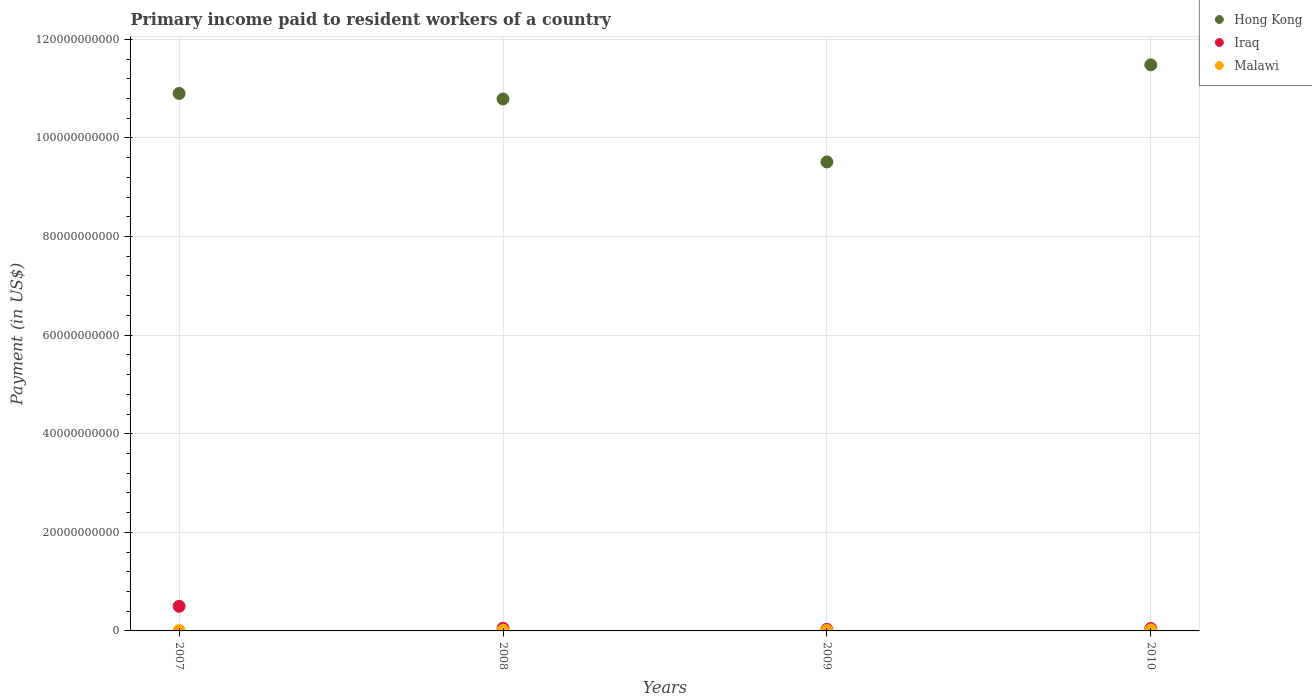What is the amount paid to workers in Hong Kong in 2009?
Ensure brevity in your answer.  9.51e+1. Across all years, what is the maximum amount paid to workers in Hong Kong?
Your answer should be very brief. 1.15e+11. Across all years, what is the minimum amount paid to workers in Hong Kong?
Make the answer very short. 9.51e+1. In which year was the amount paid to workers in Malawi maximum?
Offer a very short reply. 2010. What is the total amount paid to workers in Hong Kong in the graph?
Your answer should be very brief. 4.27e+11. What is the difference between the amount paid to workers in Iraq in 2007 and that in 2010?
Provide a succinct answer. 4.50e+09. What is the difference between the amount paid to workers in Iraq in 2009 and the amount paid to workers in Malawi in 2010?
Your response must be concise. 1.25e+08. What is the average amount paid to workers in Hong Kong per year?
Provide a short and direct response. 1.07e+11. In the year 2010, what is the difference between the amount paid to workers in Iraq and amount paid to workers in Hong Kong?
Provide a short and direct response. -1.14e+11. What is the ratio of the amount paid to workers in Malawi in 2009 to that in 2010?
Your answer should be very brief. 0.64. Is the amount paid to workers in Hong Kong in 2007 less than that in 2010?
Provide a succinct answer. Yes. What is the difference between the highest and the second highest amount paid to workers in Hong Kong?
Your answer should be very brief. 5.80e+09. What is the difference between the highest and the lowest amount paid to workers in Iraq?
Provide a succinct answer. 4.67e+09. In how many years, is the amount paid to workers in Iraq greater than the average amount paid to workers in Iraq taken over all years?
Provide a short and direct response. 1. Does the amount paid to workers in Malawi monotonically increase over the years?
Keep it short and to the point. No. Is the amount paid to workers in Malawi strictly greater than the amount paid to workers in Iraq over the years?
Provide a succinct answer. No. Is the amount paid to workers in Hong Kong strictly less than the amount paid to workers in Malawi over the years?
Offer a terse response. No. Where does the legend appear in the graph?
Your answer should be compact. Top right. What is the title of the graph?
Your response must be concise. Primary income paid to resident workers of a country. Does "Senegal" appear as one of the legend labels in the graph?
Give a very brief answer. No. What is the label or title of the X-axis?
Provide a short and direct response. Years. What is the label or title of the Y-axis?
Your answer should be compact. Payment (in US$). What is the Payment (in US$) in Hong Kong in 2007?
Your answer should be compact. 1.09e+11. What is the Payment (in US$) of Iraq in 2007?
Provide a succinct answer. 4.99e+09. What is the Payment (in US$) of Malawi in 2007?
Offer a very short reply. 8.07e+07. What is the Payment (in US$) in Hong Kong in 2008?
Ensure brevity in your answer.  1.08e+11. What is the Payment (in US$) of Iraq in 2008?
Your answer should be very brief. 5.54e+08. What is the Payment (in US$) in Malawi in 2008?
Give a very brief answer. 1.50e+08. What is the Payment (in US$) of Hong Kong in 2009?
Provide a short and direct response. 9.51e+1. What is the Payment (in US$) of Iraq in 2009?
Your answer should be compact. 3.17e+08. What is the Payment (in US$) in Malawi in 2009?
Make the answer very short. 1.23e+08. What is the Payment (in US$) of Hong Kong in 2010?
Provide a short and direct response. 1.15e+11. What is the Payment (in US$) in Iraq in 2010?
Offer a terse response. 4.87e+08. What is the Payment (in US$) in Malawi in 2010?
Provide a short and direct response. 1.92e+08. Across all years, what is the maximum Payment (in US$) of Hong Kong?
Give a very brief answer. 1.15e+11. Across all years, what is the maximum Payment (in US$) in Iraq?
Offer a terse response. 4.99e+09. Across all years, what is the maximum Payment (in US$) of Malawi?
Provide a succinct answer. 1.92e+08. Across all years, what is the minimum Payment (in US$) in Hong Kong?
Your response must be concise. 9.51e+1. Across all years, what is the minimum Payment (in US$) in Iraq?
Your answer should be very brief. 3.17e+08. Across all years, what is the minimum Payment (in US$) of Malawi?
Give a very brief answer. 8.07e+07. What is the total Payment (in US$) in Hong Kong in the graph?
Offer a terse response. 4.27e+11. What is the total Payment (in US$) in Iraq in the graph?
Make the answer very short. 6.35e+09. What is the total Payment (in US$) of Malawi in the graph?
Offer a very short reply. 5.45e+08. What is the difference between the Payment (in US$) of Hong Kong in 2007 and that in 2008?
Offer a very short reply. 1.12e+09. What is the difference between the Payment (in US$) of Iraq in 2007 and that in 2008?
Provide a short and direct response. 4.44e+09. What is the difference between the Payment (in US$) in Malawi in 2007 and that in 2008?
Provide a short and direct response. -6.90e+07. What is the difference between the Payment (in US$) of Hong Kong in 2007 and that in 2009?
Provide a short and direct response. 1.39e+1. What is the difference between the Payment (in US$) in Iraq in 2007 and that in 2009?
Your response must be concise. 4.67e+09. What is the difference between the Payment (in US$) in Malawi in 2007 and that in 2009?
Your answer should be compact. -4.18e+07. What is the difference between the Payment (in US$) in Hong Kong in 2007 and that in 2010?
Ensure brevity in your answer.  -5.80e+09. What is the difference between the Payment (in US$) in Iraq in 2007 and that in 2010?
Offer a very short reply. 4.50e+09. What is the difference between the Payment (in US$) of Malawi in 2007 and that in 2010?
Your answer should be compact. -1.12e+08. What is the difference between the Payment (in US$) in Hong Kong in 2008 and that in 2009?
Keep it short and to the point. 1.28e+1. What is the difference between the Payment (in US$) in Iraq in 2008 and that in 2009?
Give a very brief answer. 2.36e+08. What is the difference between the Payment (in US$) in Malawi in 2008 and that in 2009?
Your answer should be compact. 2.73e+07. What is the difference between the Payment (in US$) in Hong Kong in 2008 and that in 2010?
Provide a short and direct response. -6.93e+09. What is the difference between the Payment (in US$) in Iraq in 2008 and that in 2010?
Provide a succinct answer. 6.69e+07. What is the difference between the Payment (in US$) in Malawi in 2008 and that in 2010?
Offer a very short reply. -4.25e+07. What is the difference between the Payment (in US$) of Hong Kong in 2009 and that in 2010?
Offer a terse response. -1.97e+1. What is the difference between the Payment (in US$) in Iraq in 2009 and that in 2010?
Give a very brief answer. -1.70e+08. What is the difference between the Payment (in US$) in Malawi in 2009 and that in 2010?
Provide a succinct answer. -6.97e+07. What is the difference between the Payment (in US$) of Hong Kong in 2007 and the Payment (in US$) of Iraq in 2008?
Keep it short and to the point. 1.08e+11. What is the difference between the Payment (in US$) in Hong Kong in 2007 and the Payment (in US$) in Malawi in 2008?
Your response must be concise. 1.09e+11. What is the difference between the Payment (in US$) in Iraq in 2007 and the Payment (in US$) in Malawi in 2008?
Make the answer very short. 4.84e+09. What is the difference between the Payment (in US$) of Hong Kong in 2007 and the Payment (in US$) of Iraq in 2009?
Make the answer very short. 1.09e+11. What is the difference between the Payment (in US$) of Hong Kong in 2007 and the Payment (in US$) of Malawi in 2009?
Offer a terse response. 1.09e+11. What is the difference between the Payment (in US$) in Iraq in 2007 and the Payment (in US$) in Malawi in 2009?
Keep it short and to the point. 4.87e+09. What is the difference between the Payment (in US$) of Hong Kong in 2007 and the Payment (in US$) of Iraq in 2010?
Your answer should be very brief. 1.09e+11. What is the difference between the Payment (in US$) in Hong Kong in 2007 and the Payment (in US$) in Malawi in 2010?
Ensure brevity in your answer.  1.09e+11. What is the difference between the Payment (in US$) of Iraq in 2007 and the Payment (in US$) of Malawi in 2010?
Provide a short and direct response. 4.80e+09. What is the difference between the Payment (in US$) in Hong Kong in 2008 and the Payment (in US$) in Iraq in 2009?
Keep it short and to the point. 1.08e+11. What is the difference between the Payment (in US$) in Hong Kong in 2008 and the Payment (in US$) in Malawi in 2009?
Keep it short and to the point. 1.08e+11. What is the difference between the Payment (in US$) in Iraq in 2008 and the Payment (in US$) in Malawi in 2009?
Provide a succinct answer. 4.31e+08. What is the difference between the Payment (in US$) in Hong Kong in 2008 and the Payment (in US$) in Iraq in 2010?
Keep it short and to the point. 1.07e+11. What is the difference between the Payment (in US$) of Hong Kong in 2008 and the Payment (in US$) of Malawi in 2010?
Provide a short and direct response. 1.08e+11. What is the difference between the Payment (in US$) of Iraq in 2008 and the Payment (in US$) of Malawi in 2010?
Ensure brevity in your answer.  3.61e+08. What is the difference between the Payment (in US$) in Hong Kong in 2009 and the Payment (in US$) in Iraq in 2010?
Offer a terse response. 9.46e+1. What is the difference between the Payment (in US$) in Hong Kong in 2009 and the Payment (in US$) in Malawi in 2010?
Provide a short and direct response. 9.49e+1. What is the difference between the Payment (in US$) in Iraq in 2009 and the Payment (in US$) in Malawi in 2010?
Keep it short and to the point. 1.25e+08. What is the average Payment (in US$) of Hong Kong per year?
Your answer should be very brief. 1.07e+11. What is the average Payment (in US$) in Iraq per year?
Make the answer very short. 1.59e+09. What is the average Payment (in US$) of Malawi per year?
Your response must be concise. 1.36e+08. In the year 2007, what is the difference between the Payment (in US$) in Hong Kong and Payment (in US$) in Iraq?
Your response must be concise. 1.04e+11. In the year 2007, what is the difference between the Payment (in US$) of Hong Kong and Payment (in US$) of Malawi?
Give a very brief answer. 1.09e+11. In the year 2007, what is the difference between the Payment (in US$) of Iraq and Payment (in US$) of Malawi?
Your answer should be compact. 4.91e+09. In the year 2008, what is the difference between the Payment (in US$) in Hong Kong and Payment (in US$) in Iraq?
Ensure brevity in your answer.  1.07e+11. In the year 2008, what is the difference between the Payment (in US$) of Hong Kong and Payment (in US$) of Malawi?
Provide a short and direct response. 1.08e+11. In the year 2008, what is the difference between the Payment (in US$) in Iraq and Payment (in US$) in Malawi?
Ensure brevity in your answer.  4.04e+08. In the year 2009, what is the difference between the Payment (in US$) in Hong Kong and Payment (in US$) in Iraq?
Your answer should be compact. 9.48e+1. In the year 2009, what is the difference between the Payment (in US$) of Hong Kong and Payment (in US$) of Malawi?
Your answer should be compact. 9.50e+1. In the year 2009, what is the difference between the Payment (in US$) in Iraq and Payment (in US$) in Malawi?
Make the answer very short. 1.95e+08. In the year 2010, what is the difference between the Payment (in US$) of Hong Kong and Payment (in US$) of Iraq?
Offer a very short reply. 1.14e+11. In the year 2010, what is the difference between the Payment (in US$) of Hong Kong and Payment (in US$) of Malawi?
Your response must be concise. 1.15e+11. In the year 2010, what is the difference between the Payment (in US$) of Iraq and Payment (in US$) of Malawi?
Offer a very short reply. 2.94e+08. What is the ratio of the Payment (in US$) in Hong Kong in 2007 to that in 2008?
Ensure brevity in your answer.  1.01. What is the ratio of the Payment (in US$) in Iraq in 2007 to that in 2008?
Give a very brief answer. 9.01. What is the ratio of the Payment (in US$) of Malawi in 2007 to that in 2008?
Offer a very short reply. 0.54. What is the ratio of the Payment (in US$) of Hong Kong in 2007 to that in 2009?
Ensure brevity in your answer.  1.15. What is the ratio of the Payment (in US$) of Iraq in 2007 to that in 2009?
Your answer should be compact. 15.74. What is the ratio of the Payment (in US$) of Malawi in 2007 to that in 2009?
Provide a short and direct response. 0.66. What is the ratio of the Payment (in US$) in Hong Kong in 2007 to that in 2010?
Your response must be concise. 0.95. What is the ratio of the Payment (in US$) of Iraq in 2007 to that in 2010?
Provide a succinct answer. 10.25. What is the ratio of the Payment (in US$) of Malawi in 2007 to that in 2010?
Make the answer very short. 0.42. What is the ratio of the Payment (in US$) of Hong Kong in 2008 to that in 2009?
Ensure brevity in your answer.  1.13. What is the ratio of the Payment (in US$) of Iraq in 2008 to that in 2009?
Keep it short and to the point. 1.75. What is the ratio of the Payment (in US$) of Malawi in 2008 to that in 2009?
Make the answer very short. 1.22. What is the ratio of the Payment (in US$) of Hong Kong in 2008 to that in 2010?
Ensure brevity in your answer.  0.94. What is the ratio of the Payment (in US$) of Iraq in 2008 to that in 2010?
Make the answer very short. 1.14. What is the ratio of the Payment (in US$) in Malawi in 2008 to that in 2010?
Offer a very short reply. 0.78. What is the ratio of the Payment (in US$) of Hong Kong in 2009 to that in 2010?
Your response must be concise. 0.83. What is the ratio of the Payment (in US$) in Iraq in 2009 to that in 2010?
Keep it short and to the point. 0.65. What is the ratio of the Payment (in US$) in Malawi in 2009 to that in 2010?
Make the answer very short. 0.64. What is the difference between the highest and the second highest Payment (in US$) in Hong Kong?
Keep it short and to the point. 5.80e+09. What is the difference between the highest and the second highest Payment (in US$) of Iraq?
Your response must be concise. 4.44e+09. What is the difference between the highest and the second highest Payment (in US$) of Malawi?
Provide a succinct answer. 4.25e+07. What is the difference between the highest and the lowest Payment (in US$) in Hong Kong?
Make the answer very short. 1.97e+1. What is the difference between the highest and the lowest Payment (in US$) of Iraq?
Your answer should be very brief. 4.67e+09. What is the difference between the highest and the lowest Payment (in US$) in Malawi?
Offer a very short reply. 1.12e+08. 